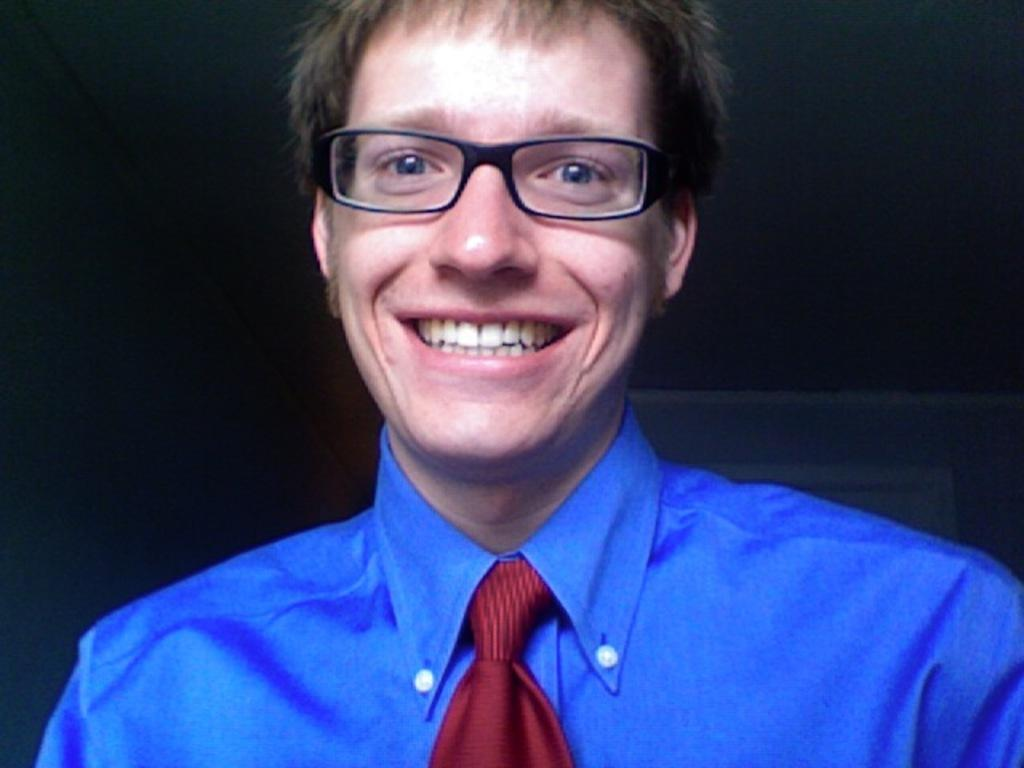What is the main subject of the image? There is a person in the image. What is the person wearing on their upper body? The person is wearing a blue shirt. What accessory is the person wearing around their neck? The person is wearing a red tie. What can be seen on the person's face? The person is wearing spectacles and smiling. What is the color of the background in the image? The background of the image is dark. What type of creature is sitting on the person's shoulder in the image? There is no creature present on the person's shoulder in the image. What credit card does the person have in their wallet in the image? There is no information about the person's wallet or credit cards in the image. 